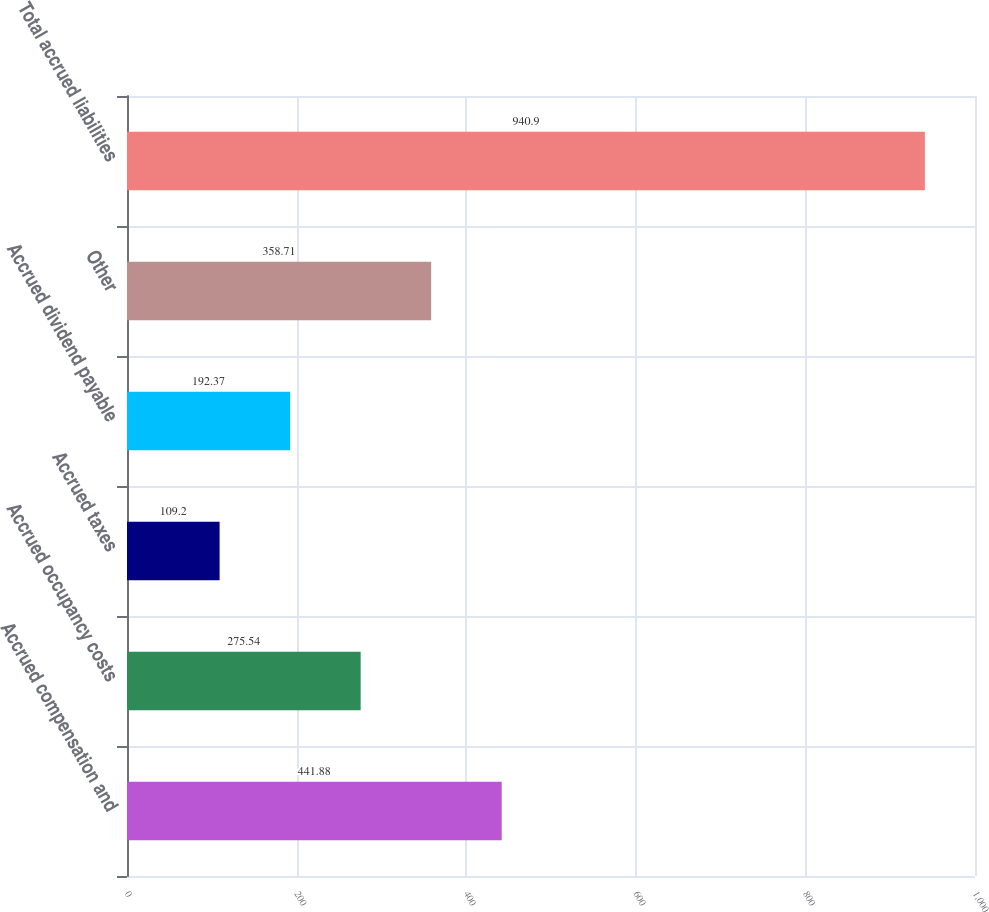Convert chart. <chart><loc_0><loc_0><loc_500><loc_500><bar_chart><fcel>Accrued compensation and<fcel>Accrued occupancy costs<fcel>Accrued taxes<fcel>Accrued dividend payable<fcel>Other<fcel>Total accrued liabilities<nl><fcel>441.88<fcel>275.54<fcel>109.2<fcel>192.37<fcel>358.71<fcel>940.9<nl></chart> 